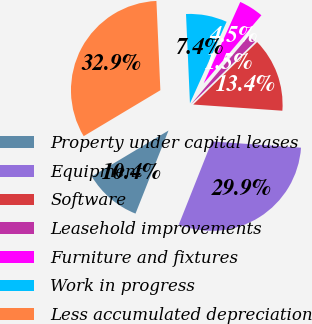Convert chart to OTSL. <chart><loc_0><loc_0><loc_500><loc_500><pie_chart><fcel>Property under capital leases<fcel>Equipment<fcel>Software<fcel>Leasehold improvements<fcel>Furniture and fixtures<fcel>Work in progress<fcel>Less accumulated depreciation<nl><fcel>10.39%<fcel>29.92%<fcel>13.42%<fcel>1.5%<fcel>4.46%<fcel>7.43%<fcel>32.89%<nl></chart> 